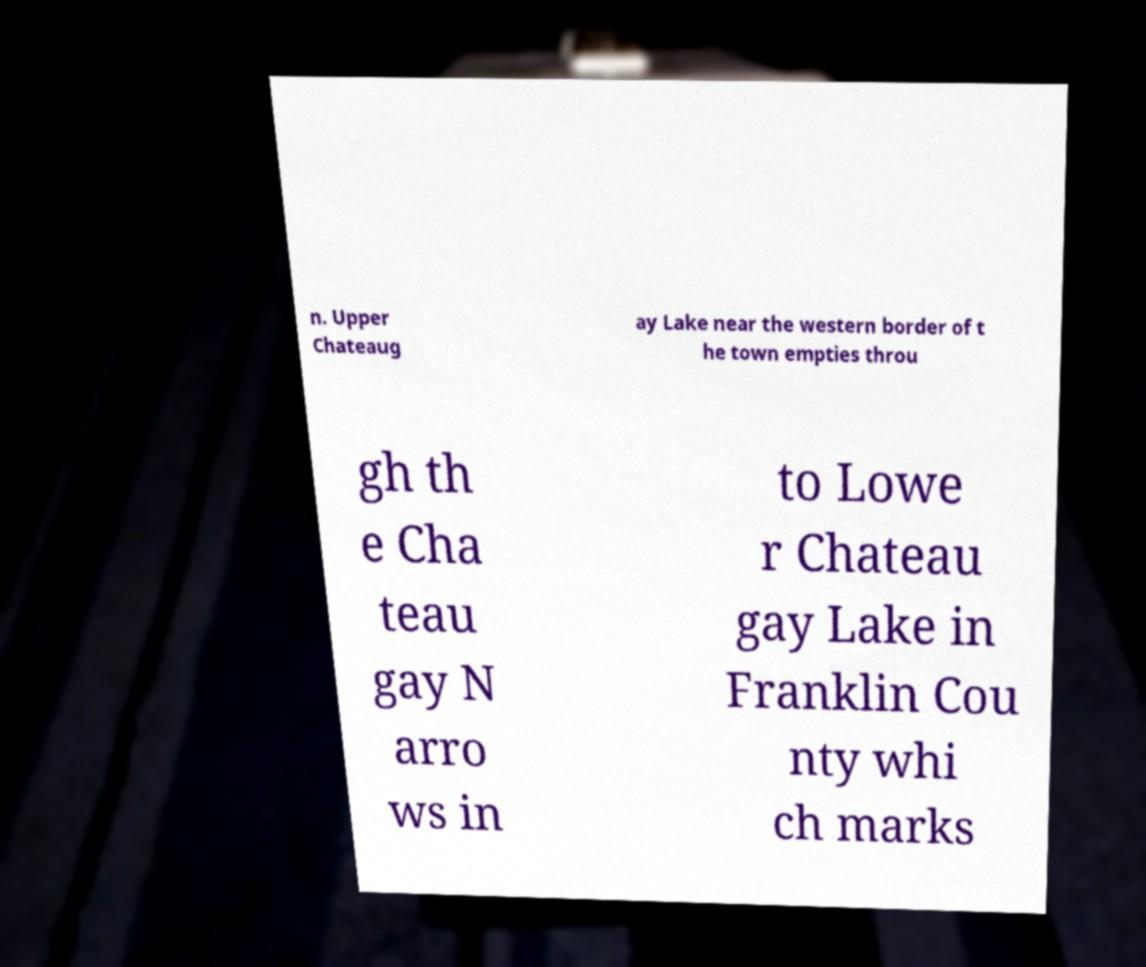Could you assist in decoding the text presented in this image and type it out clearly? n. Upper Chateaug ay Lake near the western border of t he town empties throu gh th e Cha teau gay N arro ws in to Lowe r Chateau gay Lake in Franklin Cou nty whi ch marks 